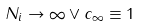Convert formula to latex. <formula><loc_0><loc_0><loc_500><loc_500>N _ { i } \to \infty \vee c _ { \infty } \equiv 1</formula> 